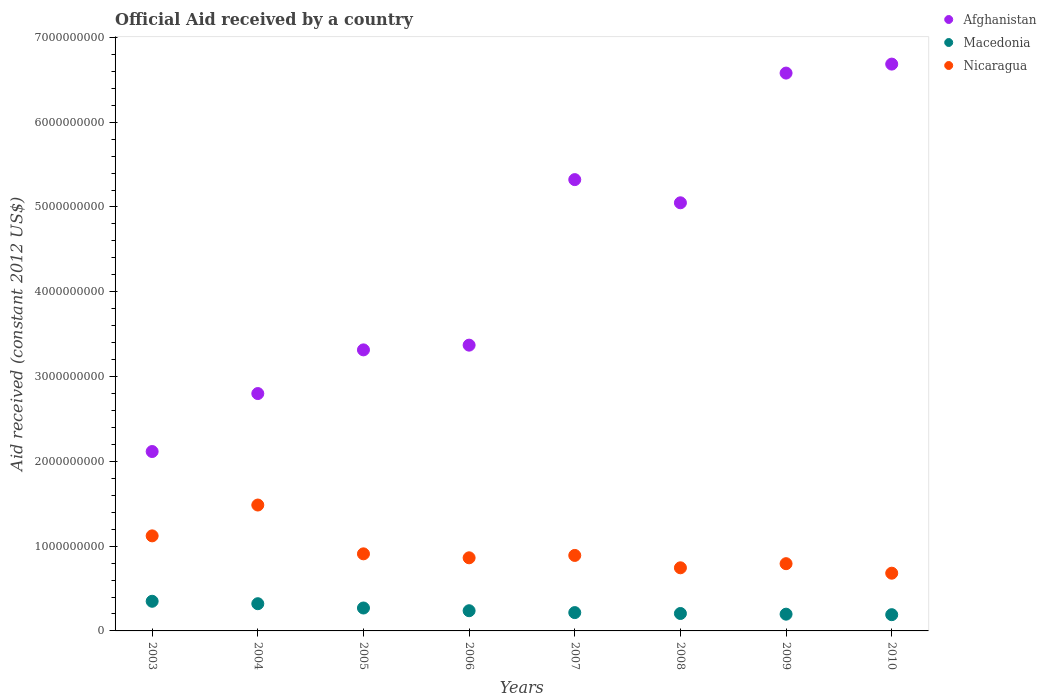How many different coloured dotlines are there?
Offer a very short reply. 3. Is the number of dotlines equal to the number of legend labels?
Keep it short and to the point. Yes. What is the net official aid received in Macedonia in 2007?
Your answer should be compact. 2.16e+08. Across all years, what is the maximum net official aid received in Macedonia?
Provide a short and direct response. 3.50e+08. Across all years, what is the minimum net official aid received in Nicaragua?
Provide a short and direct response. 6.81e+08. In which year was the net official aid received in Macedonia maximum?
Offer a very short reply. 2003. In which year was the net official aid received in Nicaragua minimum?
Give a very brief answer. 2010. What is the total net official aid received in Afghanistan in the graph?
Offer a terse response. 3.52e+1. What is the difference between the net official aid received in Macedonia in 2003 and that in 2005?
Offer a terse response. 7.94e+07. What is the difference between the net official aid received in Afghanistan in 2003 and the net official aid received in Macedonia in 2005?
Keep it short and to the point. 1.85e+09. What is the average net official aid received in Nicaragua per year?
Your response must be concise. 9.36e+08. In the year 2008, what is the difference between the net official aid received in Macedonia and net official aid received in Afghanistan?
Provide a short and direct response. -4.84e+09. What is the ratio of the net official aid received in Afghanistan in 2009 to that in 2010?
Your answer should be compact. 0.98. Is the net official aid received in Afghanistan in 2004 less than that in 2009?
Offer a terse response. Yes. Is the difference between the net official aid received in Macedonia in 2004 and 2010 greater than the difference between the net official aid received in Afghanistan in 2004 and 2010?
Make the answer very short. Yes. What is the difference between the highest and the second highest net official aid received in Macedonia?
Your answer should be very brief. 2.86e+07. What is the difference between the highest and the lowest net official aid received in Afghanistan?
Keep it short and to the point. 4.57e+09. In how many years, is the net official aid received in Nicaragua greater than the average net official aid received in Nicaragua taken over all years?
Provide a short and direct response. 2. Is the sum of the net official aid received in Afghanistan in 2003 and 2005 greater than the maximum net official aid received in Nicaragua across all years?
Make the answer very short. Yes. Are the values on the major ticks of Y-axis written in scientific E-notation?
Your answer should be very brief. No. Does the graph contain any zero values?
Your answer should be very brief. No. Where does the legend appear in the graph?
Provide a succinct answer. Top right. How many legend labels are there?
Your response must be concise. 3. What is the title of the graph?
Your answer should be compact. Official Aid received by a country. Does "Japan" appear as one of the legend labels in the graph?
Ensure brevity in your answer.  No. What is the label or title of the Y-axis?
Provide a succinct answer. Aid received (constant 2012 US$). What is the Aid received (constant 2012 US$) in Afghanistan in 2003?
Offer a terse response. 2.12e+09. What is the Aid received (constant 2012 US$) of Macedonia in 2003?
Provide a short and direct response. 3.50e+08. What is the Aid received (constant 2012 US$) of Nicaragua in 2003?
Your answer should be very brief. 1.12e+09. What is the Aid received (constant 2012 US$) of Afghanistan in 2004?
Your answer should be compact. 2.80e+09. What is the Aid received (constant 2012 US$) of Macedonia in 2004?
Keep it short and to the point. 3.21e+08. What is the Aid received (constant 2012 US$) in Nicaragua in 2004?
Provide a short and direct response. 1.48e+09. What is the Aid received (constant 2012 US$) in Afghanistan in 2005?
Offer a very short reply. 3.31e+09. What is the Aid received (constant 2012 US$) of Macedonia in 2005?
Your answer should be compact. 2.70e+08. What is the Aid received (constant 2012 US$) of Nicaragua in 2005?
Provide a short and direct response. 9.09e+08. What is the Aid received (constant 2012 US$) of Afghanistan in 2006?
Make the answer very short. 3.37e+09. What is the Aid received (constant 2012 US$) in Macedonia in 2006?
Provide a short and direct response. 2.38e+08. What is the Aid received (constant 2012 US$) in Nicaragua in 2006?
Your answer should be compact. 8.62e+08. What is the Aid received (constant 2012 US$) of Afghanistan in 2007?
Offer a very short reply. 5.32e+09. What is the Aid received (constant 2012 US$) in Macedonia in 2007?
Offer a terse response. 2.16e+08. What is the Aid received (constant 2012 US$) of Nicaragua in 2007?
Ensure brevity in your answer.  8.90e+08. What is the Aid received (constant 2012 US$) of Afghanistan in 2008?
Provide a succinct answer. 5.05e+09. What is the Aid received (constant 2012 US$) in Macedonia in 2008?
Your response must be concise. 2.06e+08. What is the Aid received (constant 2012 US$) in Nicaragua in 2008?
Your answer should be compact. 7.44e+08. What is the Aid received (constant 2012 US$) in Afghanistan in 2009?
Provide a short and direct response. 6.58e+09. What is the Aid received (constant 2012 US$) of Macedonia in 2009?
Keep it short and to the point. 1.98e+08. What is the Aid received (constant 2012 US$) in Nicaragua in 2009?
Keep it short and to the point. 7.93e+08. What is the Aid received (constant 2012 US$) in Afghanistan in 2010?
Your answer should be very brief. 6.68e+09. What is the Aid received (constant 2012 US$) of Macedonia in 2010?
Your answer should be very brief. 1.92e+08. What is the Aid received (constant 2012 US$) in Nicaragua in 2010?
Give a very brief answer. 6.81e+08. Across all years, what is the maximum Aid received (constant 2012 US$) in Afghanistan?
Give a very brief answer. 6.68e+09. Across all years, what is the maximum Aid received (constant 2012 US$) of Macedonia?
Offer a terse response. 3.50e+08. Across all years, what is the maximum Aid received (constant 2012 US$) of Nicaragua?
Offer a very short reply. 1.48e+09. Across all years, what is the minimum Aid received (constant 2012 US$) of Afghanistan?
Provide a short and direct response. 2.12e+09. Across all years, what is the minimum Aid received (constant 2012 US$) in Macedonia?
Provide a short and direct response. 1.92e+08. Across all years, what is the minimum Aid received (constant 2012 US$) in Nicaragua?
Give a very brief answer. 6.81e+08. What is the total Aid received (constant 2012 US$) in Afghanistan in the graph?
Provide a short and direct response. 3.52e+1. What is the total Aid received (constant 2012 US$) of Macedonia in the graph?
Keep it short and to the point. 1.99e+09. What is the total Aid received (constant 2012 US$) of Nicaragua in the graph?
Keep it short and to the point. 7.49e+09. What is the difference between the Aid received (constant 2012 US$) of Afghanistan in 2003 and that in 2004?
Your answer should be very brief. -6.84e+08. What is the difference between the Aid received (constant 2012 US$) of Macedonia in 2003 and that in 2004?
Offer a very short reply. 2.86e+07. What is the difference between the Aid received (constant 2012 US$) in Nicaragua in 2003 and that in 2004?
Give a very brief answer. -3.64e+08. What is the difference between the Aid received (constant 2012 US$) in Afghanistan in 2003 and that in 2005?
Offer a terse response. -1.20e+09. What is the difference between the Aid received (constant 2012 US$) of Macedonia in 2003 and that in 2005?
Make the answer very short. 7.94e+07. What is the difference between the Aid received (constant 2012 US$) in Nicaragua in 2003 and that in 2005?
Offer a terse response. 2.12e+08. What is the difference between the Aid received (constant 2012 US$) in Afghanistan in 2003 and that in 2006?
Offer a very short reply. -1.25e+09. What is the difference between the Aid received (constant 2012 US$) in Macedonia in 2003 and that in 2006?
Offer a terse response. 1.12e+08. What is the difference between the Aid received (constant 2012 US$) in Nicaragua in 2003 and that in 2006?
Your response must be concise. 2.59e+08. What is the difference between the Aid received (constant 2012 US$) of Afghanistan in 2003 and that in 2007?
Make the answer very short. -3.21e+09. What is the difference between the Aid received (constant 2012 US$) in Macedonia in 2003 and that in 2007?
Offer a terse response. 1.34e+08. What is the difference between the Aid received (constant 2012 US$) in Nicaragua in 2003 and that in 2007?
Ensure brevity in your answer.  2.31e+08. What is the difference between the Aid received (constant 2012 US$) of Afghanistan in 2003 and that in 2008?
Provide a succinct answer. -2.93e+09. What is the difference between the Aid received (constant 2012 US$) in Macedonia in 2003 and that in 2008?
Provide a short and direct response. 1.44e+08. What is the difference between the Aid received (constant 2012 US$) of Nicaragua in 2003 and that in 2008?
Give a very brief answer. 3.77e+08. What is the difference between the Aid received (constant 2012 US$) in Afghanistan in 2003 and that in 2009?
Make the answer very short. -4.46e+09. What is the difference between the Aid received (constant 2012 US$) in Macedonia in 2003 and that in 2009?
Ensure brevity in your answer.  1.52e+08. What is the difference between the Aid received (constant 2012 US$) in Nicaragua in 2003 and that in 2009?
Give a very brief answer. 3.28e+08. What is the difference between the Aid received (constant 2012 US$) of Afghanistan in 2003 and that in 2010?
Keep it short and to the point. -4.57e+09. What is the difference between the Aid received (constant 2012 US$) of Macedonia in 2003 and that in 2010?
Offer a terse response. 1.58e+08. What is the difference between the Aid received (constant 2012 US$) of Nicaragua in 2003 and that in 2010?
Your response must be concise. 4.40e+08. What is the difference between the Aid received (constant 2012 US$) of Afghanistan in 2004 and that in 2005?
Offer a very short reply. -5.15e+08. What is the difference between the Aid received (constant 2012 US$) of Macedonia in 2004 and that in 2005?
Make the answer very short. 5.08e+07. What is the difference between the Aid received (constant 2012 US$) of Nicaragua in 2004 and that in 2005?
Make the answer very short. 5.76e+08. What is the difference between the Aid received (constant 2012 US$) in Afghanistan in 2004 and that in 2006?
Your answer should be very brief. -5.71e+08. What is the difference between the Aid received (constant 2012 US$) of Macedonia in 2004 and that in 2006?
Ensure brevity in your answer.  8.29e+07. What is the difference between the Aid received (constant 2012 US$) in Nicaragua in 2004 and that in 2006?
Keep it short and to the point. 6.22e+08. What is the difference between the Aid received (constant 2012 US$) of Afghanistan in 2004 and that in 2007?
Give a very brief answer. -2.52e+09. What is the difference between the Aid received (constant 2012 US$) of Macedonia in 2004 and that in 2007?
Make the answer very short. 1.05e+08. What is the difference between the Aid received (constant 2012 US$) in Nicaragua in 2004 and that in 2007?
Your answer should be compact. 5.94e+08. What is the difference between the Aid received (constant 2012 US$) of Afghanistan in 2004 and that in 2008?
Your answer should be very brief. -2.25e+09. What is the difference between the Aid received (constant 2012 US$) in Macedonia in 2004 and that in 2008?
Make the answer very short. 1.15e+08. What is the difference between the Aid received (constant 2012 US$) in Nicaragua in 2004 and that in 2008?
Provide a succinct answer. 7.40e+08. What is the difference between the Aid received (constant 2012 US$) of Afghanistan in 2004 and that in 2009?
Provide a short and direct response. -3.78e+09. What is the difference between the Aid received (constant 2012 US$) in Macedonia in 2004 and that in 2009?
Keep it short and to the point. 1.23e+08. What is the difference between the Aid received (constant 2012 US$) of Nicaragua in 2004 and that in 2009?
Keep it short and to the point. 6.92e+08. What is the difference between the Aid received (constant 2012 US$) of Afghanistan in 2004 and that in 2010?
Offer a very short reply. -3.89e+09. What is the difference between the Aid received (constant 2012 US$) in Macedonia in 2004 and that in 2010?
Give a very brief answer. 1.29e+08. What is the difference between the Aid received (constant 2012 US$) of Nicaragua in 2004 and that in 2010?
Your response must be concise. 8.04e+08. What is the difference between the Aid received (constant 2012 US$) of Afghanistan in 2005 and that in 2006?
Offer a very short reply. -5.58e+07. What is the difference between the Aid received (constant 2012 US$) in Macedonia in 2005 and that in 2006?
Keep it short and to the point. 3.21e+07. What is the difference between the Aid received (constant 2012 US$) of Nicaragua in 2005 and that in 2006?
Your answer should be very brief. 4.68e+07. What is the difference between the Aid received (constant 2012 US$) in Afghanistan in 2005 and that in 2007?
Offer a very short reply. -2.01e+09. What is the difference between the Aid received (constant 2012 US$) of Macedonia in 2005 and that in 2007?
Your answer should be very brief. 5.42e+07. What is the difference between the Aid received (constant 2012 US$) of Nicaragua in 2005 and that in 2007?
Your answer should be very brief. 1.87e+07. What is the difference between the Aid received (constant 2012 US$) of Afghanistan in 2005 and that in 2008?
Your answer should be very brief. -1.73e+09. What is the difference between the Aid received (constant 2012 US$) of Macedonia in 2005 and that in 2008?
Offer a very short reply. 6.47e+07. What is the difference between the Aid received (constant 2012 US$) in Nicaragua in 2005 and that in 2008?
Your answer should be compact. 1.65e+08. What is the difference between the Aid received (constant 2012 US$) in Afghanistan in 2005 and that in 2009?
Your answer should be compact. -3.26e+09. What is the difference between the Aid received (constant 2012 US$) in Macedonia in 2005 and that in 2009?
Keep it short and to the point. 7.27e+07. What is the difference between the Aid received (constant 2012 US$) in Nicaragua in 2005 and that in 2009?
Your response must be concise. 1.16e+08. What is the difference between the Aid received (constant 2012 US$) of Afghanistan in 2005 and that in 2010?
Your answer should be very brief. -3.37e+09. What is the difference between the Aid received (constant 2012 US$) in Macedonia in 2005 and that in 2010?
Ensure brevity in your answer.  7.87e+07. What is the difference between the Aid received (constant 2012 US$) of Nicaragua in 2005 and that in 2010?
Your answer should be compact. 2.28e+08. What is the difference between the Aid received (constant 2012 US$) of Afghanistan in 2006 and that in 2007?
Your answer should be very brief. -1.95e+09. What is the difference between the Aid received (constant 2012 US$) of Macedonia in 2006 and that in 2007?
Provide a succinct answer. 2.21e+07. What is the difference between the Aid received (constant 2012 US$) of Nicaragua in 2006 and that in 2007?
Give a very brief answer. -2.80e+07. What is the difference between the Aid received (constant 2012 US$) of Afghanistan in 2006 and that in 2008?
Your answer should be compact. -1.68e+09. What is the difference between the Aid received (constant 2012 US$) in Macedonia in 2006 and that in 2008?
Your answer should be compact. 3.26e+07. What is the difference between the Aid received (constant 2012 US$) in Nicaragua in 2006 and that in 2008?
Provide a short and direct response. 1.18e+08. What is the difference between the Aid received (constant 2012 US$) in Afghanistan in 2006 and that in 2009?
Keep it short and to the point. -3.21e+09. What is the difference between the Aid received (constant 2012 US$) in Macedonia in 2006 and that in 2009?
Your answer should be compact. 4.06e+07. What is the difference between the Aid received (constant 2012 US$) in Nicaragua in 2006 and that in 2009?
Your answer should be compact. 6.93e+07. What is the difference between the Aid received (constant 2012 US$) of Afghanistan in 2006 and that in 2010?
Make the answer very short. -3.31e+09. What is the difference between the Aid received (constant 2012 US$) in Macedonia in 2006 and that in 2010?
Provide a succinct answer. 4.66e+07. What is the difference between the Aid received (constant 2012 US$) of Nicaragua in 2006 and that in 2010?
Ensure brevity in your answer.  1.81e+08. What is the difference between the Aid received (constant 2012 US$) in Afghanistan in 2007 and that in 2008?
Provide a succinct answer. 2.73e+08. What is the difference between the Aid received (constant 2012 US$) in Macedonia in 2007 and that in 2008?
Provide a succinct answer. 1.05e+07. What is the difference between the Aid received (constant 2012 US$) in Nicaragua in 2007 and that in 2008?
Ensure brevity in your answer.  1.46e+08. What is the difference between the Aid received (constant 2012 US$) of Afghanistan in 2007 and that in 2009?
Keep it short and to the point. -1.26e+09. What is the difference between the Aid received (constant 2012 US$) of Macedonia in 2007 and that in 2009?
Your answer should be compact. 1.85e+07. What is the difference between the Aid received (constant 2012 US$) in Nicaragua in 2007 and that in 2009?
Provide a succinct answer. 9.73e+07. What is the difference between the Aid received (constant 2012 US$) of Afghanistan in 2007 and that in 2010?
Your answer should be compact. -1.36e+09. What is the difference between the Aid received (constant 2012 US$) in Macedonia in 2007 and that in 2010?
Offer a very short reply. 2.45e+07. What is the difference between the Aid received (constant 2012 US$) in Nicaragua in 2007 and that in 2010?
Ensure brevity in your answer.  2.09e+08. What is the difference between the Aid received (constant 2012 US$) in Afghanistan in 2008 and that in 2009?
Offer a very short reply. -1.53e+09. What is the difference between the Aid received (constant 2012 US$) of Macedonia in 2008 and that in 2009?
Your answer should be very brief. 8.01e+06. What is the difference between the Aid received (constant 2012 US$) in Nicaragua in 2008 and that in 2009?
Make the answer very short. -4.85e+07. What is the difference between the Aid received (constant 2012 US$) of Afghanistan in 2008 and that in 2010?
Keep it short and to the point. -1.64e+09. What is the difference between the Aid received (constant 2012 US$) in Macedonia in 2008 and that in 2010?
Your answer should be very brief. 1.40e+07. What is the difference between the Aid received (constant 2012 US$) of Nicaragua in 2008 and that in 2010?
Make the answer very short. 6.36e+07. What is the difference between the Aid received (constant 2012 US$) of Afghanistan in 2009 and that in 2010?
Keep it short and to the point. -1.06e+08. What is the difference between the Aid received (constant 2012 US$) in Macedonia in 2009 and that in 2010?
Ensure brevity in your answer.  6.03e+06. What is the difference between the Aid received (constant 2012 US$) in Nicaragua in 2009 and that in 2010?
Your answer should be compact. 1.12e+08. What is the difference between the Aid received (constant 2012 US$) of Afghanistan in 2003 and the Aid received (constant 2012 US$) of Macedonia in 2004?
Your response must be concise. 1.79e+09. What is the difference between the Aid received (constant 2012 US$) in Afghanistan in 2003 and the Aid received (constant 2012 US$) in Nicaragua in 2004?
Provide a short and direct response. 6.31e+08. What is the difference between the Aid received (constant 2012 US$) of Macedonia in 2003 and the Aid received (constant 2012 US$) of Nicaragua in 2004?
Offer a very short reply. -1.14e+09. What is the difference between the Aid received (constant 2012 US$) of Afghanistan in 2003 and the Aid received (constant 2012 US$) of Macedonia in 2005?
Your answer should be compact. 1.85e+09. What is the difference between the Aid received (constant 2012 US$) in Afghanistan in 2003 and the Aid received (constant 2012 US$) in Nicaragua in 2005?
Offer a very short reply. 1.21e+09. What is the difference between the Aid received (constant 2012 US$) of Macedonia in 2003 and the Aid received (constant 2012 US$) of Nicaragua in 2005?
Ensure brevity in your answer.  -5.59e+08. What is the difference between the Aid received (constant 2012 US$) of Afghanistan in 2003 and the Aid received (constant 2012 US$) of Macedonia in 2006?
Keep it short and to the point. 1.88e+09. What is the difference between the Aid received (constant 2012 US$) of Afghanistan in 2003 and the Aid received (constant 2012 US$) of Nicaragua in 2006?
Provide a succinct answer. 1.25e+09. What is the difference between the Aid received (constant 2012 US$) of Macedonia in 2003 and the Aid received (constant 2012 US$) of Nicaragua in 2006?
Provide a succinct answer. -5.13e+08. What is the difference between the Aid received (constant 2012 US$) in Afghanistan in 2003 and the Aid received (constant 2012 US$) in Macedonia in 2007?
Your answer should be compact. 1.90e+09. What is the difference between the Aid received (constant 2012 US$) of Afghanistan in 2003 and the Aid received (constant 2012 US$) of Nicaragua in 2007?
Your answer should be very brief. 1.23e+09. What is the difference between the Aid received (constant 2012 US$) in Macedonia in 2003 and the Aid received (constant 2012 US$) in Nicaragua in 2007?
Offer a very short reply. -5.41e+08. What is the difference between the Aid received (constant 2012 US$) of Afghanistan in 2003 and the Aid received (constant 2012 US$) of Macedonia in 2008?
Offer a terse response. 1.91e+09. What is the difference between the Aid received (constant 2012 US$) of Afghanistan in 2003 and the Aid received (constant 2012 US$) of Nicaragua in 2008?
Your answer should be compact. 1.37e+09. What is the difference between the Aid received (constant 2012 US$) of Macedonia in 2003 and the Aid received (constant 2012 US$) of Nicaragua in 2008?
Make the answer very short. -3.95e+08. What is the difference between the Aid received (constant 2012 US$) of Afghanistan in 2003 and the Aid received (constant 2012 US$) of Macedonia in 2009?
Provide a short and direct response. 1.92e+09. What is the difference between the Aid received (constant 2012 US$) of Afghanistan in 2003 and the Aid received (constant 2012 US$) of Nicaragua in 2009?
Provide a short and direct response. 1.32e+09. What is the difference between the Aid received (constant 2012 US$) in Macedonia in 2003 and the Aid received (constant 2012 US$) in Nicaragua in 2009?
Keep it short and to the point. -4.43e+08. What is the difference between the Aid received (constant 2012 US$) of Afghanistan in 2003 and the Aid received (constant 2012 US$) of Macedonia in 2010?
Provide a succinct answer. 1.92e+09. What is the difference between the Aid received (constant 2012 US$) in Afghanistan in 2003 and the Aid received (constant 2012 US$) in Nicaragua in 2010?
Provide a succinct answer. 1.43e+09. What is the difference between the Aid received (constant 2012 US$) of Macedonia in 2003 and the Aid received (constant 2012 US$) of Nicaragua in 2010?
Your answer should be very brief. -3.31e+08. What is the difference between the Aid received (constant 2012 US$) in Afghanistan in 2004 and the Aid received (constant 2012 US$) in Macedonia in 2005?
Make the answer very short. 2.53e+09. What is the difference between the Aid received (constant 2012 US$) in Afghanistan in 2004 and the Aid received (constant 2012 US$) in Nicaragua in 2005?
Offer a terse response. 1.89e+09. What is the difference between the Aid received (constant 2012 US$) of Macedonia in 2004 and the Aid received (constant 2012 US$) of Nicaragua in 2005?
Provide a succinct answer. -5.88e+08. What is the difference between the Aid received (constant 2012 US$) of Afghanistan in 2004 and the Aid received (constant 2012 US$) of Macedonia in 2006?
Offer a very short reply. 2.56e+09. What is the difference between the Aid received (constant 2012 US$) of Afghanistan in 2004 and the Aid received (constant 2012 US$) of Nicaragua in 2006?
Keep it short and to the point. 1.94e+09. What is the difference between the Aid received (constant 2012 US$) in Macedonia in 2004 and the Aid received (constant 2012 US$) in Nicaragua in 2006?
Offer a terse response. -5.41e+08. What is the difference between the Aid received (constant 2012 US$) in Afghanistan in 2004 and the Aid received (constant 2012 US$) in Macedonia in 2007?
Your answer should be very brief. 2.58e+09. What is the difference between the Aid received (constant 2012 US$) of Afghanistan in 2004 and the Aid received (constant 2012 US$) of Nicaragua in 2007?
Give a very brief answer. 1.91e+09. What is the difference between the Aid received (constant 2012 US$) of Macedonia in 2004 and the Aid received (constant 2012 US$) of Nicaragua in 2007?
Your response must be concise. -5.69e+08. What is the difference between the Aid received (constant 2012 US$) of Afghanistan in 2004 and the Aid received (constant 2012 US$) of Macedonia in 2008?
Provide a succinct answer. 2.59e+09. What is the difference between the Aid received (constant 2012 US$) of Afghanistan in 2004 and the Aid received (constant 2012 US$) of Nicaragua in 2008?
Offer a terse response. 2.05e+09. What is the difference between the Aid received (constant 2012 US$) in Macedonia in 2004 and the Aid received (constant 2012 US$) in Nicaragua in 2008?
Your answer should be very brief. -4.23e+08. What is the difference between the Aid received (constant 2012 US$) of Afghanistan in 2004 and the Aid received (constant 2012 US$) of Macedonia in 2009?
Provide a succinct answer. 2.60e+09. What is the difference between the Aid received (constant 2012 US$) of Afghanistan in 2004 and the Aid received (constant 2012 US$) of Nicaragua in 2009?
Give a very brief answer. 2.01e+09. What is the difference between the Aid received (constant 2012 US$) of Macedonia in 2004 and the Aid received (constant 2012 US$) of Nicaragua in 2009?
Offer a very short reply. -4.72e+08. What is the difference between the Aid received (constant 2012 US$) in Afghanistan in 2004 and the Aid received (constant 2012 US$) in Macedonia in 2010?
Offer a very short reply. 2.61e+09. What is the difference between the Aid received (constant 2012 US$) of Afghanistan in 2004 and the Aid received (constant 2012 US$) of Nicaragua in 2010?
Keep it short and to the point. 2.12e+09. What is the difference between the Aid received (constant 2012 US$) in Macedonia in 2004 and the Aid received (constant 2012 US$) in Nicaragua in 2010?
Offer a terse response. -3.60e+08. What is the difference between the Aid received (constant 2012 US$) of Afghanistan in 2005 and the Aid received (constant 2012 US$) of Macedonia in 2006?
Provide a short and direct response. 3.08e+09. What is the difference between the Aid received (constant 2012 US$) of Afghanistan in 2005 and the Aid received (constant 2012 US$) of Nicaragua in 2006?
Offer a very short reply. 2.45e+09. What is the difference between the Aid received (constant 2012 US$) in Macedonia in 2005 and the Aid received (constant 2012 US$) in Nicaragua in 2006?
Provide a succinct answer. -5.92e+08. What is the difference between the Aid received (constant 2012 US$) in Afghanistan in 2005 and the Aid received (constant 2012 US$) in Macedonia in 2007?
Your answer should be compact. 3.10e+09. What is the difference between the Aid received (constant 2012 US$) of Afghanistan in 2005 and the Aid received (constant 2012 US$) of Nicaragua in 2007?
Provide a succinct answer. 2.42e+09. What is the difference between the Aid received (constant 2012 US$) in Macedonia in 2005 and the Aid received (constant 2012 US$) in Nicaragua in 2007?
Offer a very short reply. -6.20e+08. What is the difference between the Aid received (constant 2012 US$) in Afghanistan in 2005 and the Aid received (constant 2012 US$) in Macedonia in 2008?
Offer a very short reply. 3.11e+09. What is the difference between the Aid received (constant 2012 US$) in Afghanistan in 2005 and the Aid received (constant 2012 US$) in Nicaragua in 2008?
Make the answer very short. 2.57e+09. What is the difference between the Aid received (constant 2012 US$) of Macedonia in 2005 and the Aid received (constant 2012 US$) of Nicaragua in 2008?
Your answer should be very brief. -4.74e+08. What is the difference between the Aid received (constant 2012 US$) of Afghanistan in 2005 and the Aid received (constant 2012 US$) of Macedonia in 2009?
Keep it short and to the point. 3.12e+09. What is the difference between the Aid received (constant 2012 US$) of Afghanistan in 2005 and the Aid received (constant 2012 US$) of Nicaragua in 2009?
Make the answer very short. 2.52e+09. What is the difference between the Aid received (constant 2012 US$) of Macedonia in 2005 and the Aid received (constant 2012 US$) of Nicaragua in 2009?
Provide a succinct answer. -5.23e+08. What is the difference between the Aid received (constant 2012 US$) of Afghanistan in 2005 and the Aid received (constant 2012 US$) of Macedonia in 2010?
Provide a short and direct response. 3.12e+09. What is the difference between the Aid received (constant 2012 US$) of Afghanistan in 2005 and the Aid received (constant 2012 US$) of Nicaragua in 2010?
Ensure brevity in your answer.  2.63e+09. What is the difference between the Aid received (constant 2012 US$) in Macedonia in 2005 and the Aid received (constant 2012 US$) in Nicaragua in 2010?
Your response must be concise. -4.11e+08. What is the difference between the Aid received (constant 2012 US$) in Afghanistan in 2006 and the Aid received (constant 2012 US$) in Macedonia in 2007?
Your answer should be compact. 3.15e+09. What is the difference between the Aid received (constant 2012 US$) of Afghanistan in 2006 and the Aid received (constant 2012 US$) of Nicaragua in 2007?
Your answer should be compact. 2.48e+09. What is the difference between the Aid received (constant 2012 US$) of Macedonia in 2006 and the Aid received (constant 2012 US$) of Nicaragua in 2007?
Provide a short and direct response. -6.52e+08. What is the difference between the Aid received (constant 2012 US$) in Afghanistan in 2006 and the Aid received (constant 2012 US$) in Macedonia in 2008?
Make the answer very short. 3.16e+09. What is the difference between the Aid received (constant 2012 US$) in Afghanistan in 2006 and the Aid received (constant 2012 US$) in Nicaragua in 2008?
Provide a succinct answer. 2.63e+09. What is the difference between the Aid received (constant 2012 US$) of Macedonia in 2006 and the Aid received (constant 2012 US$) of Nicaragua in 2008?
Provide a succinct answer. -5.06e+08. What is the difference between the Aid received (constant 2012 US$) of Afghanistan in 2006 and the Aid received (constant 2012 US$) of Macedonia in 2009?
Make the answer very short. 3.17e+09. What is the difference between the Aid received (constant 2012 US$) of Afghanistan in 2006 and the Aid received (constant 2012 US$) of Nicaragua in 2009?
Provide a short and direct response. 2.58e+09. What is the difference between the Aid received (constant 2012 US$) in Macedonia in 2006 and the Aid received (constant 2012 US$) in Nicaragua in 2009?
Your answer should be very brief. -5.55e+08. What is the difference between the Aid received (constant 2012 US$) of Afghanistan in 2006 and the Aid received (constant 2012 US$) of Macedonia in 2010?
Ensure brevity in your answer.  3.18e+09. What is the difference between the Aid received (constant 2012 US$) in Afghanistan in 2006 and the Aid received (constant 2012 US$) in Nicaragua in 2010?
Offer a very short reply. 2.69e+09. What is the difference between the Aid received (constant 2012 US$) of Macedonia in 2006 and the Aid received (constant 2012 US$) of Nicaragua in 2010?
Your answer should be very brief. -4.43e+08. What is the difference between the Aid received (constant 2012 US$) of Afghanistan in 2007 and the Aid received (constant 2012 US$) of Macedonia in 2008?
Offer a terse response. 5.12e+09. What is the difference between the Aid received (constant 2012 US$) of Afghanistan in 2007 and the Aid received (constant 2012 US$) of Nicaragua in 2008?
Your answer should be very brief. 4.58e+09. What is the difference between the Aid received (constant 2012 US$) of Macedonia in 2007 and the Aid received (constant 2012 US$) of Nicaragua in 2008?
Your response must be concise. -5.28e+08. What is the difference between the Aid received (constant 2012 US$) of Afghanistan in 2007 and the Aid received (constant 2012 US$) of Macedonia in 2009?
Your response must be concise. 5.12e+09. What is the difference between the Aid received (constant 2012 US$) of Afghanistan in 2007 and the Aid received (constant 2012 US$) of Nicaragua in 2009?
Make the answer very short. 4.53e+09. What is the difference between the Aid received (constant 2012 US$) in Macedonia in 2007 and the Aid received (constant 2012 US$) in Nicaragua in 2009?
Offer a terse response. -5.77e+08. What is the difference between the Aid received (constant 2012 US$) of Afghanistan in 2007 and the Aid received (constant 2012 US$) of Macedonia in 2010?
Provide a short and direct response. 5.13e+09. What is the difference between the Aid received (constant 2012 US$) of Afghanistan in 2007 and the Aid received (constant 2012 US$) of Nicaragua in 2010?
Your answer should be very brief. 4.64e+09. What is the difference between the Aid received (constant 2012 US$) in Macedonia in 2007 and the Aid received (constant 2012 US$) in Nicaragua in 2010?
Make the answer very short. -4.65e+08. What is the difference between the Aid received (constant 2012 US$) of Afghanistan in 2008 and the Aid received (constant 2012 US$) of Macedonia in 2009?
Your answer should be compact. 4.85e+09. What is the difference between the Aid received (constant 2012 US$) in Afghanistan in 2008 and the Aid received (constant 2012 US$) in Nicaragua in 2009?
Give a very brief answer. 4.26e+09. What is the difference between the Aid received (constant 2012 US$) of Macedonia in 2008 and the Aid received (constant 2012 US$) of Nicaragua in 2009?
Offer a very short reply. -5.87e+08. What is the difference between the Aid received (constant 2012 US$) in Afghanistan in 2008 and the Aid received (constant 2012 US$) in Macedonia in 2010?
Offer a very short reply. 4.86e+09. What is the difference between the Aid received (constant 2012 US$) in Afghanistan in 2008 and the Aid received (constant 2012 US$) in Nicaragua in 2010?
Ensure brevity in your answer.  4.37e+09. What is the difference between the Aid received (constant 2012 US$) of Macedonia in 2008 and the Aid received (constant 2012 US$) of Nicaragua in 2010?
Keep it short and to the point. -4.75e+08. What is the difference between the Aid received (constant 2012 US$) in Afghanistan in 2009 and the Aid received (constant 2012 US$) in Macedonia in 2010?
Provide a short and direct response. 6.39e+09. What is the difference between the Aid received (constant 2012 US$) of Afghanistan in 2009 and the Aid received (constant 2012 US$) of Nicaragua in 2010?
Your answer should be very brief. 5.90e+09. What is the difference between the Aid received (constant 2012 US$) of Macedonia in 2009 and the Aid received (constant 2012 US$) of Nicaragua in 2010?
Make the answer very short. -4.83e+08. What is the average Aid received (constant 2012 US$) of Afghanistan per year?
Provide a succinct answer. 4.40e+09. What is the average Aid received (constant 2012 US$) in Macedonia per year?
Provide a short and direct response. 2.49e+08. What is the average Aid received (constant 2012 US$) in Nicaragua per year?
Provide a succinct answer. 9.36e+08. In the year 2003, what is the difference between the Aid received (constant 2012 US$) in Afghanistan and Aid received (constant 2012 US$) in Macedonia?
Provide a short and direct response. 1.77e+09. In the year 2003, what is the difference between the Aid received (constant 2012 US$) in Afghanistan and Aid received (constant 2012 US$) in Nicaragua?
Your answer should be compact. 9.95e+08. In the year 2003, what is the difference between the Aid received (constant 2012 US$) of Macedonia and Aid received (constant 2012 US$) of Nicaragua?
Give a very brief answer. -7.71e+08. In the year 2004, what is the difference between the Aid received (constant 2012 US$) in Afghanistan and Aid received (constant 2012 US$) in Macedonia?
Your answer should be compact. 2.48e+09. In the year 2004, what is the difference between the Aid received (constant 2012 US$) in Afghanistan and Aid received (constant 2012 US$) in Nicaragua?
Keep it short and to the point. 1.31e+09. In the year 2004, what is the difference between the Aid received (constant 2012 US$) in Macedonia and Aid received (constant 2012 US$) in Nicaragua?
Keep it short and to the point. -1.16e+09. In the year 2005, what is the difference between the Aid received (constant 2012 US$) in Afghanistan and Aid received (constant 2012 US$) in Macedonia?
Ensure brevity in your answer.  3.04e+09. In the year 2005, what is the difference between the Aid received (constant 2012 US$) of Afghanistan and Aid received (constant 2012 US$) of Nicaragua?
Provide a succinct answer. 2.41e+09. In the year 2005, what is the difference between the Aid received (constant 2012 US$) of Macedonia and Aid received (constant 2012 US$) of Nicaragua?
Your response must be concise. -6.39e+08. In the year 2006, what is the difference between the Aid received (constant 2012 US$) of Afghanistan and Aid received (constant 2012 US$) of Macedonia?
Provide a short and direct response. 3.13e+09. In the year 2006, what is the difference between the Aid received (constant 2012 US$) in Afghanistan and Aid received (constant 2012 US$) in Nicaragua?
Ensure brevity in your answer.  2.51e+09. In the year 2006, what is the difference between the Aid received (constant 2012 US$) in Macedonia and Aid received (constant 2012 US$) in Nicaragua?
Keep it short and to the point. -6.24e+08. In the year 2007, what is the difference between the Aid received (constant 2012 US$) in Afghanistan and Aid received (constant 2012 US$) in Macedonia?
Provide a succinct answer. 5.11e+09. In the year 2007, what is the difference between the Aid received (constant 2012 US$) in Afghanistan and Aid received (constant 2012 US$) in Nicaragua?
Your answer should be compact. 4.43e+09. In the year 2007, what is the difference between the Aid received (constant 2012 US$) in Macedonia and Aid received (constant 2012 US$) in Nicaragua?
Offer a very short reply. -6.74e+08. In the year 2008, what is the difference between the Aid received (constant 2012 US$) in Afghanistan and Aid received (constant 2012 US$) in Macedonia?
Make the answer very short. 4.84e+09. In the year 2008, what is the difference between the Aid received (constant 2012 US$) of Afghanistan and Aid received (constant 2012 US$) of Nicaragua?
Your answer should be compact. 4.30e+09. In the year 2008, what is the difference between the Aid received (constant 2012 US$) in Macedonia and Aid received (constant 2012 US$) in Nicaragua?
Provide a succinct answer. -5.39e+08. In the year 2009, what is the difference between the Aid received (constant 2012 US$) of Afghanistan and Aid received (constant 2012 US$) of Macedonia?
Provide a short and direct response. 6.38e+09. In the year 2009, what is the difference between the Aid received (constant 2012 US$) in Afghanistan and Aid received (constant 2012 US$) in Nicaragua?
Your response must be concise. 5.79e+09. In the year 2009, what is the difference between the Aid received (constant 2012 US$) of Macedonia and Aid received (constant 2012 US$) of Nicaragua?
Provide a short and direct response. -5.95e+08. In the year 2010, what is the difference between the Aid received (constant 2012 US$) in Afghanistan and Aid received (constant 2012 US$) in Macedonia?
Provide a succinct answer. 6.49e+09. In the year 2010, what is the difference between the Aid received (constant 2012 US$) of Afghanistan and Aid received (constant 2012 US$) of Nicaragua?
Offer a terse response. 6.00e+09. In the year 2010, what is the difference between the Aid received (constant 2012 US$) of Macedonia and Aid received (constant 2012 US$) of Nicaragua?
Your answer should be compact. -4.89e+08. What is the ratio of the Aid received (constant 2012 US$) in Afghanistan in 2003 to that in 2004?
Provide a short and direct response. 0.76. What is the ratio of the Aid received (constant 2012 US$) of Macedonia in 2003 to that in 2004?
Ensure brevity in your answer.  1.09. What is the ratio of the Aid received (constant 2012 US$) of Nicaragua in 2003 to that in 2004?
Your answer should be very brief. 0.76. What is the ratio of the Aid received (constant 2012 US$) in Afghanistan in 2003 to that in 2005?
Make the answer very short. 0.64. What is the ratio of the Aid received (constant 2012 US$) in Macedonia in 2003 to that in 2005?
Your response must be concise. 1.29. What is the ratio of the Aid received (constant 2012 US$) of Nicaragua in 2003 to that in 2005?
Offer a terse response. 1.23. What is the ratio of the Aid received (constant 2012 US$) of Afghanistan in 2003 to that in 2006?
Provide a succinct answer. 0.63. What is the ratio of the Aid received (constant 2012 US$) of Macedonia in 2003 to that in 2006?
Give a very brief answer. 1.47. What is the ratio of the Aid received (constant 2012 US$) of Nicaragua in 2003 to that in 2006?
Offer a terse response. 1.3. What is the ratio of the Aid received (constant 2012 US$) of Afghanistan in 2003 to that in 2007?
Offer a terse response. 0.4. What is the ratio of the Aid received (constant 2012 US$) of Macedonia in 2003 to that in 2007?
Provide a succinct answer. 1.62. What is the ratio of the Aid received (constant 2012 US$) of Nicaragua in 2003 to that in 2007?
Offer a very short reply. 1.26. What is the ratio of the Aid received (constant 2012 US$) of Afghanistan in 2003 to that in 2008?
Your answer should be very brief. 0.42. What is the ratio of the Aid received (constant 2012 US$) in Macedonia in 2003 to that in 2008?
Offer a terse response. 1.7. What is the ratio of the Aid received (constant 2012 US$) of Nicaragua in 2003 to that in 2008?
Ensure brevity in your answer.  1.51. What is the ratio of the Aid received (constant 2012 US$) of Afghanistan in 2003 to that in 2009?
Provide a succinct answer. 0.32. What is the ratio of the Aid received (constant 2012 US$) in Macedonia in 2003 to that in 2009?
Your answer should be compact. 1.77. What is the ratio of the Aid received (constant 2012 US$) of Nicaragua in 2003 to that in 2009?
Ensure brevity in your answer.  1.41. What is the ratio of the Aid received (constant 2012 US$) in Afghanistan in 2003 to that in 2010?
Your response must be concise. 0.32. What is the ratio of the Aid received (constant 2012 US$) of Macedonia in 2003 to that in 2010?
Give a very brief answer. 1.83. What is the ratio of the Aid received (constant 2012 US$) of Nicaragua in 2003 to that in 2010?
Offer a terse response. 1.65. What is the ratio of the Aid received (constant 2012 US$) of Afghanistan in 2004 to that in 2005?
Your answer should be compact. 0.84. What is the ratio of the Aid received (constant 2012 US$) in Macedonia in 2004 to that in 2005?
Provide a succinct answer. 1.19. What is the ratio of the Aid received (constant 2012 US$) of Nicaragua in 2004 to that in 2005?
Ensure brevity in your answer.  1.63. What is the ratio of the Aid received (constant 2012 US$) of Afghanistan in 2004 to that in 2006?
Ensure brevity in your answer.  0.83. What is the ratio of the Aid received (constant 2012 US$) of Macedonia in 2004 to that in 2006?
Keep it short and to the point. 1.35. What is the ratio of the Aid received (constant 2012 US$) of Nicaragua in 2004 to that in 2006?
Give a very brief answer. 1.72. What is the ratio of the Aid received (constant 2012 US$) in Afghanistan in 2004 to that in 2007?
Ensure brevity in your answer.  0.53. What is the ratio of the Aid received (constant 2012 US$) in Macedonia in 2004 to that in 2007?
Your answer should be compact. 1.49. What is the ratio of the Aid received (constant 2012 US$) of Nicaragua in 2004 to that in 2007?
Provide a short and direct response. 1.67. What is the ratio of the Aid received (constant 2012 US$) in Afghanistan in 2004 to that in 2008?
Keep it short and to the point. 0.55. What is the ratio of the Aid received (constant 2012 US$) of Macedonia in 2004 to that in 2008?
Provide a succinct answer. 1.56. What is the ratio of the Aid received (constant 2012 US$) in Nicaragua in 2004 to that in 2008?
Your response must be concise. 1.99. What is the ratio of the Aid received (constant 2012 US$) in Afghanistan in 2004 to that in 2009?
Give a very brief answer. 0.43. What is the ratio of the Aid received (constant 2012 US$) in Macedonia in 2004 to that in 2009?
Offer a terse response. 1.62. What is the ratio of the Aid received (constant 2012 US$) of Nicaragua in 2004 to that in 2009?
Offer a very short reply. 1.87. What is the ratio of the Aid received (constant 2012 US$) of Afghanistan in 2004 to that in 2010?
Provide a succinct answer. 0.42. What is the ratio of the Aid received (constant 2012 US$) of Macedonia in 2004 to that in 2010?
Keep it short and to the point. 1.68. What is the ratio of the Aid received (constant 2012 US$) of Nicaragua in 2004 to that in 2010?
Your answer should be very brief. 2.18. What is the ratio of the Aid received (constant 2012 US$) of Afghanistan in 2005 to that in 2006?
Provide a succinct answer. 0.98. What is the ratio of the Aid received (constant 2012 US$) of Macedonia in 2005 to that in 2006?
Your response must be concise. 1.13. What is the ratio of the Aid received (constant 2012 US$) of Nicaragua in 2005 to that in 2006?
Ensure brevity in your answer.  1.05. What is the ratio of the Aid received (constant 2012 US$) of Afghanistan in 2005 to that in 2007?
Keep it short and to the point. 0.62. What is the ratio of the Aid received (constant 2012 US$) of Macedonia in 2005 to that in 2007?
Provide a short and direct response. 1.25. What is the ratio of the Aid received (constant 2012 US$) in Afghanistan in 2005 to that in 2008?
Provide a succinct answer. 0.66. What is the ratio of the Aid received (constant 2012 US$) in Macedonia in 2005 to that in 2008?
Your answer should be compact. 1.31. What is the ratio of the Aid received (constant 2012 US$) in Nicaragua in 2005 to that in 2008?
Ensure brevity in your answer.  1.22. What is the ratio of the Aid received (constant 2012 US$) in Afghanistan in 2005 to that in 2009?
Your response must be concise. 0.5. What is the ratio of the Aid received (constant 2012 US$) in Macedonia in 2005 to that in 2009?
Provide a short and direct response. 1.37. What is the ratio of the Aid received (constant 2012 US$) in Nicaragua in 2005 to that in 2009?
Keep it short and to the point. 1.15. What is the ratio of the Aid received (constant 2012 US$) in Afghanistan in 2005 to that in 2010?
Your answer should be very brief. 0.5. What is the ratio of the Aid received (constant 2012 US$) in Macedonia in 2005 to that in 2010?
Offer a terse response. 1.41. What is the ratio of the Aid received (constant 2012 US$) in Nicaragua in 2005 to that in 2010?
Your answer should be very brief. 1.34. What is the ratio of the Aid received (constant 2012 US$) of Afghanistan in 2006 to that in 2007?
Provide a succinct answer. 0.63. What is the ratio of the Aid received (constant 2012 US$) in Macedonia in 2006 to that in 2007?
Your answer should be very brief. 1.1. What is the ratio of the Aid received (constant 2012 US$) in Nicaragua in 2006 to that in 2007?
Your answer should be compact. 0.97. What is the ratio of the Aid received (constant 2012 US$) of Afghanistan in 2006 to that in 2008?
Ensure brevity in your answer.  0.67. What is the ratio of the Aid received (constant 2012 US$) of Macedonia in 2006 to that in 2008?
Your answer should be compact. 1.16. What is the ratio of the Aid received (constant 2012 US$) of Nicaragua in 2006 to that in 2008?
Give a very brief answer. 1.16. What is the ratio of the Aid received (constant 2012 US$) of Afghanistan in 2006 to that in 2009?
Make the answer very short. 0.51. What is the ratio of the Aid received (constant 2012 US$) in Macedonia in 2006 to that in 2009?
Offer a very short reply. 1.21. What is the ratio of the Aid received (constant 2012 US$) of Nicaragua in 2006 to that in 2009?
Provide a succinct answer. 1.09. What is the ratio of the Aid received (constant 2012 US$) in Afghanistan in 2006 to that in 2010?
Offer a terse response. 0.5. What is the ratio of the Aid received (constant 2012 US$) of Macedonia in 2006 to that in 2010?
Provide a short and direct response. 1.24. What is the ratio of the Aid received (constant 2012 US$) of Nicaragua in 2006 to that in 2010?
Give a very brief answer. 1.27. What is the ratio of the Aid received (constant 2012 US$) in Afghanistan in 2007 to that in 2008?
Make the answer very short. 1.05. What is the ratio of the Aid received (constant 2012 US$) in Macedonia in 2007 to that in 2008?
Keep it short and to the point. 1.05. What is the ratio of the Aid received (constant 2012 US$) in Nicaragua in 2007 to that in 2008?
Give a very brief answer. 1.2. What is the ratio of the Aid received (constant 2012 US$) in Afghanistan in 2007 to that in 2009?
Ensure brevity in your answer.  0.81. What is the ratio of the Aid received (constant 2012 US$) of Macedonia in 2007 to that in 2009?
Ensure brevity in your answer.  1.09. What is the ratio of the Aid received (constant 2012 US$) of Nicaragua in 2007 to that in 2009?
Offer a very short reply. 1.12. What is the ratio of the Aid received (constant 2012 US$) in Afghanistan in 2007 to that in 2010?
Give a very brief answer. 0.8. What is the ratio of the Aid received (constant 2012 US$) in Macedonia in 2007 to that in 2010?
Your answer should be compact. 1.13. What is the ratio of the Aid received (constant 2012 US$) of Nicaragua in 2007 to that in 2010?
Ensure brevity in your answer.  1.31. What is the ratio of the Aid received (constant 2012 US$) in Afghanistan in 2008 to that in 2009?
Keep it short and to the point. 0.77. What is the ratio of the Aid received (constant 2012 US$) of Macedonia in 2008 to that in 2009?
Your answer should be very brief. 1.04. What is the ratio of the Aid received (constant 2012 US$) in Nicaragua in 2008 to that in 2009?
Provide a short and direct response. 0.94. What is the ratio of the Aid received (constant 2012 US$) in Afghanistan in 2008 to that in 2010?
Provide a succinct answer. 0.76. What is the ratio of the Aid received (constant 2012 US$) in Macedonia in 2008 to that in 2010?
Your answer should be compact. 1.07. What is the ratio of the Aid received (constant 2012 US$) of Nicaragua in 2008 to that in 2010?
Provide a short and direct response. 1.09. What is the ratio of the Aid received (constant 2012 US$) in Afghanistan in 2009 to that in 2010?
Make the answer very short. 0.98. What is the ratio of the Aid received (constant 2012 US$) of Macedonia in 2009 to that in 2010?
Offer a terse response. 1.03. What is the ratio of the Aid received (constant 2012 US$) in Nicaragua in 2009 to that in 2010?
Offer a very short reply. 1.16. What is the difference between the highest and the second highest Aid received (constant 2012 US$) in Afghanistan?
Give a very brief answer. 1.06e+08. What is the difference between the highest and the second highest Aid received (constant 2012 US$) in Macedonia?
Offer a terse response. 2.86e+07. What is the difference between the highest and the second highest Aid received (constant 2012 US$) of Nicaragua?
Offer a very short reply. 3.64e+08. What is the difference between the highest and the lowest Aid received (constant 2012 US$) of Afghanistan?
Ensure brevity in your answer.  4.57e+09. What is the difference between the highest and the lowest Aid received (constant 2012 US$) of Macedonia?
Offer a very short reply. 1.58e+08. What is the difference between the highest and the lowest Aid received (constant 2012 US$) of Nicaragua?
Make the answer very short. 8.04e+08. 